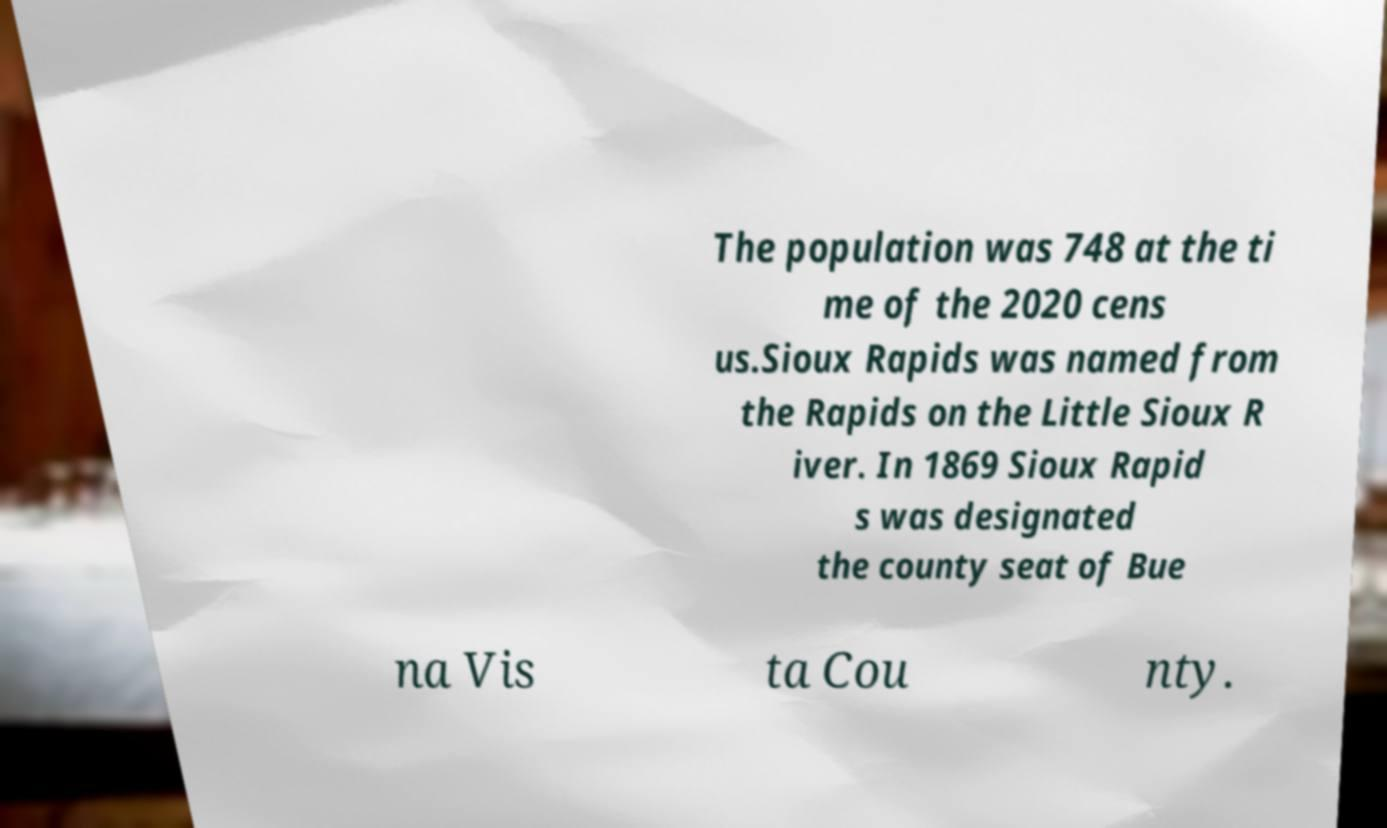I need the written content from this picture converted into text. Can you do that? The population was 748 at the ti me of the 2020 cens us.Sioux Rapids was named from the Rapids on the Little Sioux R iver. In 1869 Sioux Rapid s was designated the county seat of Bue na Vis ta Cou nty. 